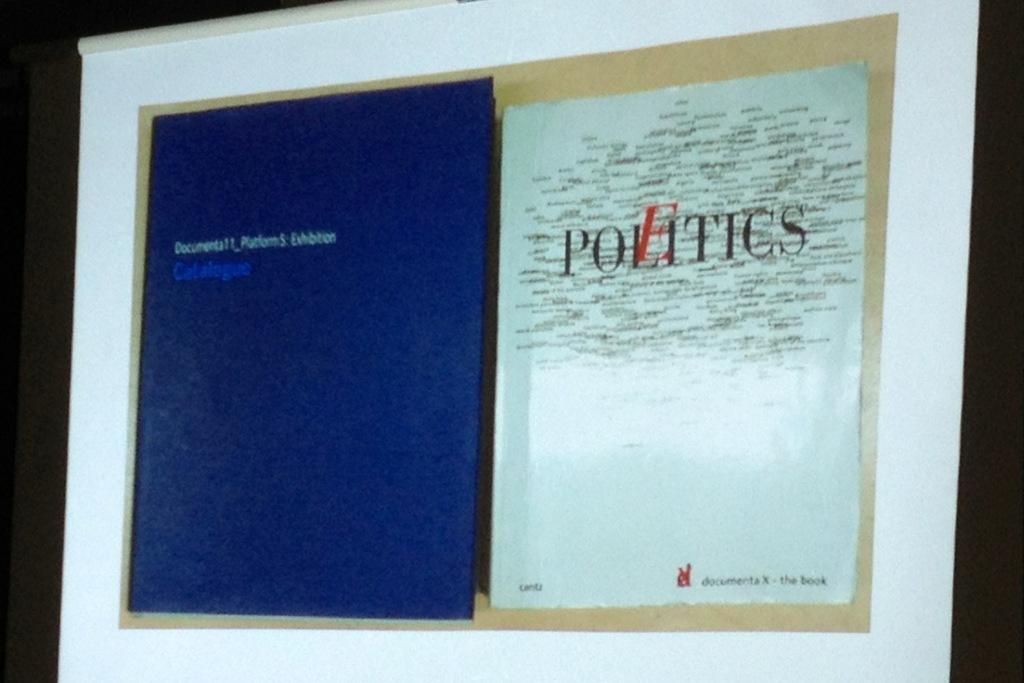What is the title of this book?
Your answer should be compact. Politics. What kind of publication is it?
Your answer should be compact. Politics. 